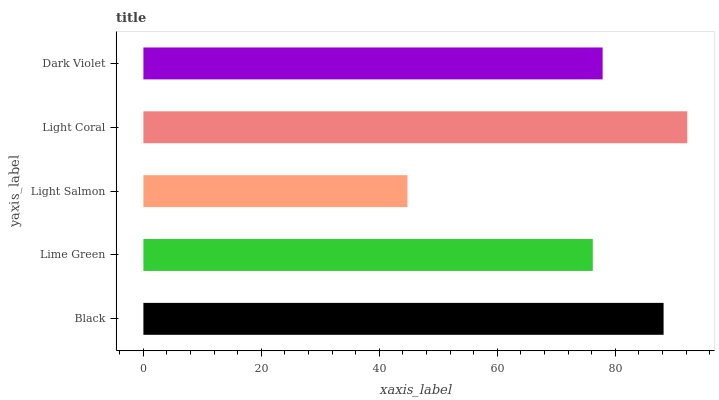Is Light Salmon the minimum?
Answer yes or no. Yes. Is Light Coral the maximum?
Answer yes or no. Yes. Is Lime Green the minimum?
Answer yes or no. No. Is Lime Green the maximum?
Answer yes or no. No. Is Black greater than Lime Green?
Answer yes or no. Yes. Is Lime Green less than Black?
Answer yes or no. Yes. Is Lime Green greater than Black?
Answer yes or no. No. Is Black less than Lime Green?
Answer yes or no. No. Is Dark Violet the high median?
Answer yes or no. Yes. Is Dark Violet the low median?
Answer yes or no. Yes. Is Light Salmon the high median?
Answer yes or no. No. Is Light Salmon the low median?
Answer yes or no. No. 